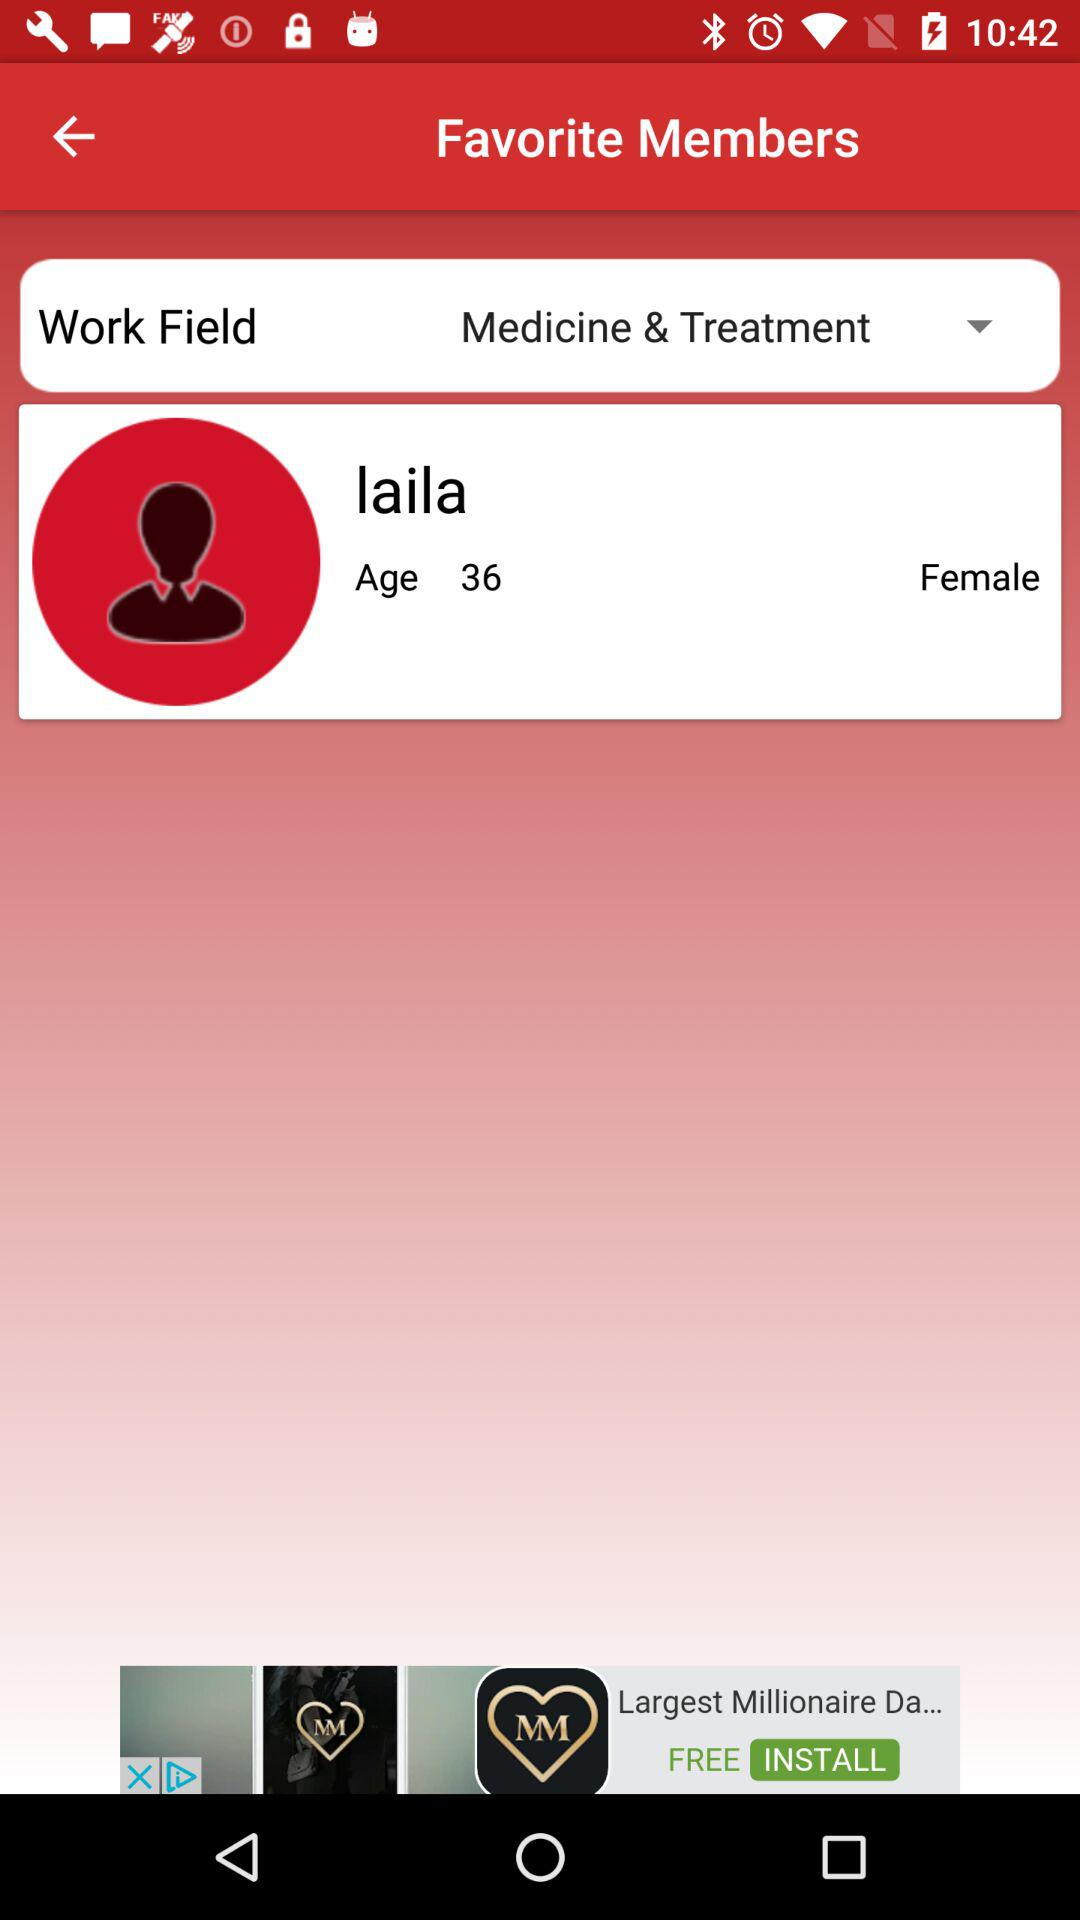What is the age of Laila? The age of Laila is 36. 